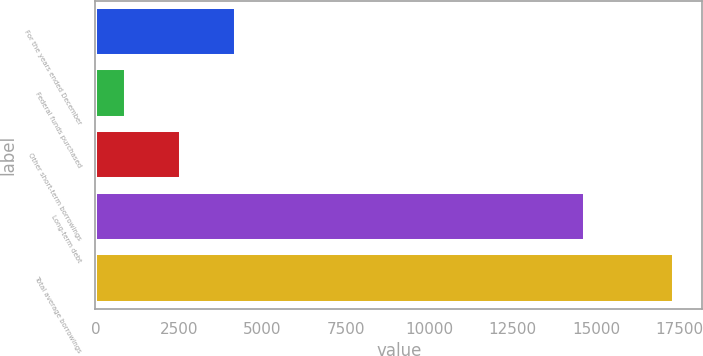Convert chart. <chart><loc_0><loc_0><loc_500><loc_500><bar_chart><fcel>For the years ended December<fcel>Federal funds purchased<fcel>Other short-term borrowings<fcel>Long-term debt<fcel>Total average borrowings<nl><fcel>4199.6<fcel>920<fcel>2559.8<fcel>14677<fcel>17318<nl></chart> 